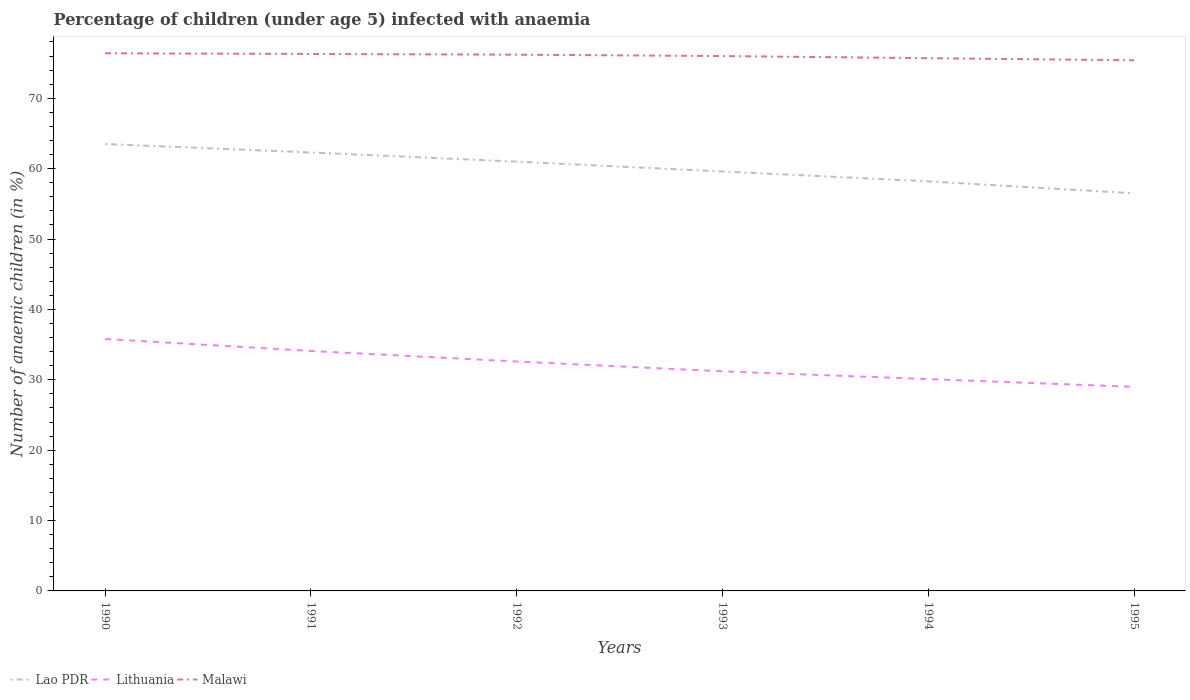Across all years, what is the maximum percentage of children infected with anaemia in in Lao PDR?
Make the answer very short. 56.5. In which year was the percentage of children infected with anaemia in in Lithuania maximum?
Your answer should be very brief. 1995. What is the total percentage of children infected with anaemia in in Lithuania in the graph?
Offer a very short reply. 1.1. What is the difference between the highest and the second highest percentage of children infected with anaemia in in Lithuania?
Offer a very short reply. 6.8. How many lines are there?
Provide a succinct answer. 3. What is the difference between two consecutive major ticks on the Y-axis?
Your answer should be very brief. 10. Does the graph contain grids?
Provide a succinct answer. No. How many legend labels are there?
Give a very brief answer. 3. What is the title of the graph?
Keep it short and to the point. Percentage of children (under age 5) infected with anaemia. What is the label or title of the Y-axis?
Provide a short and direct response. Number of anaemic children (in %). What is the Number of anaemic children (in %) in Lao PDR in 1990?
Your answer should be compact. 63.5. What is the Number of anaemic children (in %) in Lithuania in 1990?
Offer a terse response. 35.8. What is the Number of anaemic children (in %) in Malawi in 1990?
Offer a very short reply. 76.4. What is the Number of anaemic children (in %) in Lao PDR in 1991?
Offer a terse response. 62.3. What is the Number of anaemic children (in %) in Lithuania in 1991?
Your answer should be compact. 34.1. What is the Number of anaemic children (in %) in Malawi in 1991?
Ensure brevity in your answer.  76.3. What is the Number of anaemic children (in %) in Lithuania in 1992?
Ensure brevity in your answer.  32.6. What is the Number of anaemic children (in %) in Malawi in 1992?
Provide a short and direct response. 76.2. What is the Number of anaemic children (in %) in Lao PDR in 1993?
Your answer should be very brief. 59.6. What is the Number of anaemic children (in %) in Lithuania in 1993?
Offer a terse response. 31.2. What is the Number of anaemic children (in %) in Malawi in 1993?
Offer a very short reply. 76. What is the Number of anaemic children (in %) in Lao PDR in 1994?
Your answer should be compact. 58.2. What is the Number of anaemic children (in %) of Lithuania in 1994?
Give a very brief answer. 30.1. What is the Number of anaemic children (in %) in Malawi in 1994?
Provide a succinct answer. 75.7. What is the Number of anaemic children (in %) of Lao PDR in 1995?
Keep it short and to the point. 56.5. What is the Number of anaemic children (in %) in Malawi in 1995?
Provide a succinct answer. 75.4. Across all years, what is the maximum Number of anaemic children (in %) of Lao PDR?
Keep it short and to the point. 63.5. Across all years, what is the maximum Number of anaemic children (in %) of Lithuania?
Offer a very short reply. 35.8. Across all years, what is the maximum Number of anaemic children (in %) in Malawi?
Your response must be concise. 76.4. Across all years, what is the minimum Number of anaemic children (in %) of Lao PDR?
Your answer should be very brief. 56.5. Across all years, what is the minimum Number of anaemic children (in %) in Malawi?
Offer a very short reply. 75.4. What is the total Number of anaemic children (in %) of Lao PDR in the graph?
Offer a terse response. 361.1. What is the total Number of anaemic children (in %) of Lithuania in the graph?
Your answer should be very brief. 192.8. What is the total Number of anaemic children (in %) of Malawi in the graph?
Provide a succinct answer. 456. What is the difference between the Number of anaemic children (in %) of Lithuania in 1990 and that in 1991?
Offer a terse response. 1.7. What is the difference between the Number of anaemic children (in %) of Lithuania in 1990 and that in 1993?
Your response must be concise. 4.6. What is the difference between the Number of anaemic children (in %) in Malawi in 1990 and that in 1993?
Offer a terse response. 0.4. What is the difference between the Number of anaemic children (in %) in Lao PDR in 1990 and that in 1994?
Provide a short and direct response. 5.3. What is the difference between the Number of anaemic children (in %) in Lithuania in 1990 and that in 1994?
Your answer should be very brief. 5.7. What is the difference between the Number of anaemic children (in %) of Lithuania in 1991 and that in 1992?
Your answer should be very brief. 1.5. What is the difference between the Number of anaemic children (in %) of Malawi in 1991 and that in 1992?
Give a very brief answer. 0.1. What is the difference between the Number of anaemic children (in %) of Lao PDR in 1991 and that in 1993?
Your answer should be compact. 2.7. What is the difference between the Number of anaemic children (in %) in Lithuania in 1991 and that in 1993?
Offer a terse response. 2.9. What is the difference between the Number of anaemic children (in %) in Malawi in 1991 and that in 1993?
Give a very brief answer. 0.3. What is the difference between the Number of anaemic children (in %) of Lao PDR in 1991 and that in 1994?
Your answer should be compact. 4.1. What is the difference between the Number of anaemic children (in %) of Malawi in 1991 and that in 1994?
Give a very brief answer. 0.6. What is the difference between the Number of anaemic children (in %) of Malawi in 1992 and that in 1993?
Your response must be concise. 0.2. What is the difference between the Number of anaemic children (in %) in Lithuania in 1993 and that in 1994?
Offer a very short reply. 1.1. What is the difference between the Number of anaemic children (in %) in Malawi in 1993 and that in 1994?
Your response must be concise. 0.3. What is the difference between the Number of anaemic children (in %) of Lao PDR in 1994 and that in 1995?
Offer a very short reply. 1.7. What is the difference between the Number of anaemic children (in %) in Lithuania in 1994 and that in 1995?
Your answer should be very brief. 1.1. What is the difference between the Number of anaemic children (in %) of Lao PDR in 1990 and the Number of anaemic children (in %) of Lithuania in 1991?
Your answer should be very brief. 29.4. What is the difference between the Number of anaemic children (in %) of Lao PDR in 1990 and the Number of anaemic children (in %) of Malawi in 1991?
Your answer should be compact. -12.8. What is the difference between the Number of anaemic children (in %) of Lithuania in 1990 and the Number of anaemic children (in %) of Malawi in 1991?
Your answer should be very brief. -40.5. What is the difference between the Number of anaemic children (in %) in Lao PDR in 1990 and the Number of anaemic children (in %) in Lithuania in 1992?
Ensure brevity in your answer.  30.9. What is the difference between the Number of anaemic children (in %) of Lithuania in 1990 and the Number of anaemic children (in %) of Malawi in 1992?
Your answer should be compact. -40.4. What is the difference between the Number of anaemic children (in %) in Lao PDR in 1990 and the Number of anaemic children (in %) in Lithuania in 1993?
Make the answer very short. 32.3. What is the difference between the Number of anaemic children (in %) of Lao PDR in 1990 and the Number of anaemic children (in %) of Malawi in 1993?
Provide a succinct answer. -12.5. What is the difference between the Number of anaemic children (in %) in Lithuania in 1990 and the Number of anaemic children (in %) in Malawi in 1993?
Keep it short and to the point. -40.2. What is the difference between the Number of anaemic children (in %) of Lao PDR in 1990 and the Number of anaemic children (in %) of Lithuania in 1994?
Your response must be concise. 33.4. What is the difference between the Number of anaemic children (in %) in Lao PDR in 1990 and the Number of anaemic children (in %) in Malawi in 1994?
Make the answer very short. -12.2. What is the difference between the Number of anaemic children (in %) in Lithuania in 1990 and the Number of anaemic children (in %) in Malawi in 1994?
Your response must be concise. -39.9. What is the difference between the Number of anaemic children (in %) of Lao PDR in 1990 and the Number of anaemic children (in %) of Lithuania in 1995?
Keep it short and to the point. 34.5. What is the difference between the Number of anaemic children (in %) of Lithuania in 1990 and the Number of anaemic children (in %) of Malawi in 1995?
Provide a short and direct response. -39.6. What is the difference between the Number of anaemic children (in %) of Lao PDR in 1991 and the Number of anaemic children (in %) of Lithuania in 1992?
Make the answer very short. 29.7. What is the difference between the Number of anaemic children (in %) in Lao PDR in 1991 and the Number of anaemic children (in %) in Malawi in 1992?
Your answer should be very brief. -13.9. What is the difference between the Number of anaemic children (in %) in Lithuania in 1991 and the Number of anaemic children (in %) in Malawi in 1992?
Keep it short and to the point. -42.1. What is the difference between the Number of anaemic children (in %) of Lao PDR in 1991 and the Number of anaemic children (in %) of Lithuania in 1993?
Offer a terse response. 31.1. What is the difference between the Number of anaemic children (in %) in Lao PDR in 1991 and the Number of anaemic children (in %) in Malawi in 1993?
Keep it short and to the point. -13.7. What is the difference between the Number of anaemic children (in %) of Lithuania in 1991 and the Number of anaemic children (in %) of Malawi in 1993?
Offer a very short reply. -41.9. What is the difference between the Number of anaemic children (in %) of Lao PDR in 1991 and the Number of anaemic children (in %) of Lithuania in 1994?
Offer a very short reply. 32.2. What is the difference between the Number of anaemic children (in %) of Lithuania in 1991 and the Number of anaemic children (in %) of Malawi in 1994?
Offer a terse response. -41.6. What is the difference between the Number of anaemic children (in %) in Lao PDR in 1991 and the Number of anaemic children (in %) in Lithuania in 1995?
Offer a very short reply. 33.3. What is the difference between the Number of anaemic children (in %) in Lithuania in 1991 and the Number of anaemic children (in %) in Malawi in 1995?
Offer a terse response. -41.3. What is the difference between the Number of anaemic children (in %) of Lao PDR in 1992 and the Number of anaemic children (in %) of Lithuania in 1993?
Your response must be concise. 29.8. What is the difference between the Number of anaemic children (in %) of Lao PDR in 1992 and the Number of anaemic children (in %) of Malawi in 1993?
Your answer should be compact. -15. What is the difference between the Number of anaemic children (in %) in Lithuania in 1992 and the Number of anaemic children (in %) in Malawi in 1993?
Make the answer very short. -43.4. What is the difference between the Number of anaemic children (in %) of Lao PDR in 1992 and the Number of anaemic children (in %) of Lithuania in 1994?
Keep it short and to the point. 30.9. What is the difference between the Number of anaemic children (in %) of Lao PDR in 1992 and the Number of anaemic children (in %) of Malawi in 1994?
Provide a short and direct response. -14.7. What is the difference between the Number of anaemic children (in %) in Lithuania in 1992 and the Number of anaemic children (in %) in Malawi in 1994?
Your response must be concise. -43.1. What is the difference between the Number of anaemic children (in %) of Lao PDR in 1992 and the Number of anaemic children (in %) of Lithuania in 1995?
Make the answer very short. 32. What is the difference between the Number of anaemic children (in %) of Lao PDR in 1992 and the Number of anaemic children (in %) of Malawi in 1995?
Offer a very short reply. -14.4. What is the difference between the Number of anaemic children (in %) of Lithuania in 1992 and the Number of anaemic children (in %) of Malawi in 1995?
Ensure brevity in your answer.  -42.8. What is the difference between the Number of anaemic children (in %) in Lao PDR in 1993 and the Number of anaemic children (in %) in Lithuania in 1994?
Offer a very short reply. 29.5. What is the difference between the Number of anaemic children (in %) of Lao PDR in 1993 and the Number of anaemic children (in %) of Malawi in 1994?
Provide a short and direct response. -16.1. What is the difference between the Number of anaemic children (in %) in Lithuania in 1993 and the Number of anaemic children (in %) in Malawi in 1994?
Your response must be concise. -44.5. What is the difference between the Number of anaemic children (in %) in Lao PDR in 1993 and the Number of anaemic children (in %) in Lithuania in 1995?
Your answer should be compact. 30.6. What is the difference between the Number of anaemic children (in %) of Lao PDR in 1993 and the Number of anaemic children (in %) of Malawi in 1995?
Your answer should be compact. -15.8. What is the difference between the Number of anaemic children (in %) in Lithuania in 1993 and the Number of anaemic children (in %) in Malawi in 1995?
Give a very brief answer. -44.2. What is the difference between the Number of anaemic children (in %) in Lao PDR in 1994 and the Number of anaemic children (in %) in Lithuania in 1995?
Your response must be concise. 29.2. What is the difference between the Number of anaemic children (in %) in Lao PDR in 1994 and the Number of anaemic children (in %) in Malawi in 1995?
Your response must be concise. -17.2. What is the difference between the Number of anaemic children (in %) of Lithuania in 1994 and the Number of anaemic children (in %) of Malawi in 1995?
Keep it short and to the point. -45.3. What is the average Number of anaemic children (in %) in Lao PDR per year?
Give a very brief answer. 60.18. What is the average Number of anaemic children (in %) of Lithuania per year?
Make the answer very short. 32.13. In the year 1990, what is the difference between the Number of anaemic children (in %) of Lao PDR and Number of anaemic children (in %) of Lithuania?
Give a very brief answer. 27.7. In the year 1990, what is the difference between the Number of anaemic children (in %) in Lithuania and Number of anaemic children (in %) in Malawi?
Make the answer very short. -40.6. In the year 1991, what is the difference between the Number of anaemic children (in %) in Lao PDR and Number of anaemic children (in %) in Lithuania?
Offer a very short reply. 28.2. In the year 1991, what is the difference between the Number of anaemic children (in %) of Lao PDR and Number of anaemic children (in %) of Malawi?
Your answer should be very brief. -14. In the year 1991, what is the difference between the Number of anaemic children (in %) in Lithuania and Number of anaemic children (in %) in Malawi?
Your answer should be compact. -42.2. In the year 1992, what is the difference between the Number of anaemic children (in %) in Lao PDR and Number of anaemic children (in %) in Lithuania?
Offer a very short reply. 28.4. In the year 1992, what is the difference between the Number of anaemic children (in %) of Lao PDR and Number of anaemic children (in %) of Malawi?
Your answer should be compact. -15.2. In the year 1992, what is the difference between the Number of anaemic children (in %) of Lithuania and Number of anaemic children (in %) of Malawi?
Your response must be concise. -43.6. In the year 1993, what is the difference between the Number of anaemic children (in %) in Lao PDR and Number of anaemic children (in %) in Lithuania?
Ensure brevity in your answer.  28.4. In the year 1993, what is the difference between the Number of anaemic children (in %) of Lao PDR and Number of anaemic children (in %) of Malawi?
Your response must be concise. -16.4. In the year 1993, what is the difference between the Number of anaemic children (in %) in Lithuania and Number of anaemic children (in %) in Malawi?
Offer a very short reply. -44.8. In the year 1994, what is the difference between the Number of anaemic children (in %) of Lao PDR and Number of anaemic children (in %) of Lithuania?
Your answer should be compact. 28.1. In the year 1994, what is the difference between the Number of anaemic children (in %) of Lao PDR and Number of anaemic children (in %) of Malawi?
Your response must be concise. -17.5. In the year 1994, what is the difference between the Number of anaemic children (in %) in Lithuania and Number of anaemic children (in %) in Malawi?
Your response must be concise. -45.6. In the year 1995, what is the difference between the Number of anaemic children (in %) of Lao PDR and Number of anaemic children (in %) of Malawi?
Ensure brevity in your answer.  -18.9. In the year 1995, what is the difference between the Number of anaemic children (in %) in Lithuania and Number of anaemic children (in %) in Malawi?
Offer a terse response. -46.4. What is the ratio of the Number of anaemic children (in %) in Lao PDR in 1990 to that in 1991?
Offer a terse response. 1.02. What is the ratio of the Number of anaemic children (in %) in Lithuania in 1990 to that in 1991?
Provide a succinct answer. 1.05. What is the ratio of the Number of anaemic children (in %) in Malawi in 1990 to that in 1991?
Keep it short and to the point. 1. What is the ratio of the Number of anaemic children (in %) in Lao PDR in 1990 to that in 1992?
Your answer should be very brief. 1.04. What is the ratio of the Number of anaemic children (in %) of Lithuania in 1990 to that in 1992?
Your answer should be very brief. 1.1. What is the ratio of the Number of anaemic children (in %) in Lao PDR in 1990 to that in 1993?
Give a very brief answer. 1.07. What is the ratio of the Number of anaemic children (in %) in Lithuania in 1990 to that in 1993?
Offer a very short reply. 1.15. What is the ratio of the Number of anaemic children (in %) in Lao PDR in 1990 to that in 1994?
Ensure brevity in your answer.  1.09. What is the ratio of the Number of anaemic children (in %) in Lithuania in 1990 to that in 1994?
Provide a short and direct response. 1.19. What is the ratio of the Number of anaemic children (in %) of Malawi in 1990 to that in 1994?
Give a very brief answer. 1.01. What is the ratio of the Number of anaemic children (in %) in Lao PDR in 1990 to that in 1995?
Your answer should be very brief. 1.12. What is the ratio of the Number of anaemic children (in %) in Lithuania in 1990 to that in 1995?
Make the answer very short. 1.23. What is the ratio of the Number of anaemic children (in %) of Malawi in 1990 to that in 1995?
Your answer should be very brief. 1.01. What is the ratio of the Number of anaemic children (in %) of Lao PDR in 1991 to that in 1992?
Offer a very short reply. 1.02. What is the ratio of the Number of anaemic children (in %) in Lithuania in 1991 to that in 1992?
Provide a succinct answer. 1.05. What is the ratio of the Number of anaemic children (in %) in Malawi in 1991 to that in 1992?
Your response must be concise. 1. What is the ratio of the Number of anaemic children (in %) in Lao PDR in 1991 to that in 1993?
Provide a succinct answer. 1.05. What is the ratio of the Number of anaemic children (in %) in Lithuania in 1991 to that in 1993?
Ensure brevity in your answer.  1.09. What is the ratio of the Number of anaemic children (in %) of Malawi in 1991 to that in 1993?
Your response must be concise. 1. What is the ratio of the Number of anaemic children (in %) in Lao PDR in 1991 to that in 1994?
Offer a very short reply. 1.07. What is the ratio of the Number of anaemic children (in %) in Lithuania in 1991 to that in 1994?
Your response must be concise. 1.13. What is the ratio of the Number of anaemic children (in %) of Malawi in 1991 to that in 1994?
Your answer should be compact. 1.01. What is the ratio of the Number of anaemic children (in %) in Lao PDR in 1991 to that in 1995?
Your response must be concise. 1.1. What is the ratio of the Number of anaemic children (in %) of Lithuania in 1991 to that in 1995?
Provide a succinct answer. 1.18. What is the ratio of the Number of anaemic children (in %) in Malawi in 1991 to that in 1995?
Your response must be concise. 1.01. What is the ratio of the Number of anaemic children (in %) in Lao PDR in 1992 to that in 1993?
Ensure brevity in your answer.  1.02. What is the ratio of the Number of anaemic children (in %) of Lithuania in 1992 to that in 1993?
Give a very brief answer. 1.04. What is the ratio of the Number of anaemic children (in %) of Lao PDR in 1992 to that in 1994?
Your answer should be very brief. 1.05. What is the ratio of the Number of anaemic children (in %) of Lithuania in 1992 to that in 1994?
Your answer should be very brief. 1.08. What is the ratio of the Number of anaemic children (in %) of Malawi in 1992 to that in 1994?
Offer a terse response. 1.01. What is the ratio of the Number of anaemic children (in %) of Lao PDR in 1992 to that in 1995?
Provide a succinct answer. 1.08. What is the ratio of the Number of anaemic children (in %) of Lithuania in 1992 to that in 1995?
Provide a succinct answer. 1.12. What is the ratio of the Number of anaemic children (in %) in Malawi in 1992 to that in 1995?
Provide a short and direct response. 1.01. What is the ratio of the Number of anaemic children (in %) of Lao PDR in 1993 to that in 1994?
Provide a succinct answer. 1.02. What is the ratio of the Number of anaemic children (in %) in Lithuania in 1993 to that in 1994?
Your answer should be very brief. 1.04. What is the ratio of the Number of anaemic children (in %) of Malawi in 1993 to that in 1994?
Provide a short and direct response. 1. What is the ratio of the Number of anaemic children (in %) in Lao PDR in 1993 to that in 1995?
Your answer should be compact. 1.05. What is the ratio of the Number of anaemic children (in %) in Lithuania in 1993 to that in 1995?
Your answer should be very brief. 1.08. What is the ratio of the Number of anaemic children (in %) of Lao PDR in 1994 to that in 1995?
Offer a terse response. 1.03. What is the ratio of the Number of anaemic children (in %) in Lithuania in 1994 to that in 1995?
Make the answer very short. 1.04. What is the difference between the highest and the second highest Number of anaemic children (in %) of Lao PDR?
Offer a terse response. 1.2. What is the difference between the highest and the second highest Number of anaemic children (in %) in Lithuania?
Your answer should be very brief. 1.7. What is the difference between the highest and the lowest Number of anaemic children (in %) of Lao PDR?
Make the answer very short. 7. What is the difference between the highest and the lowest Number of anaemic children (in %) of Malawi?
Offer a terse response. 1. 